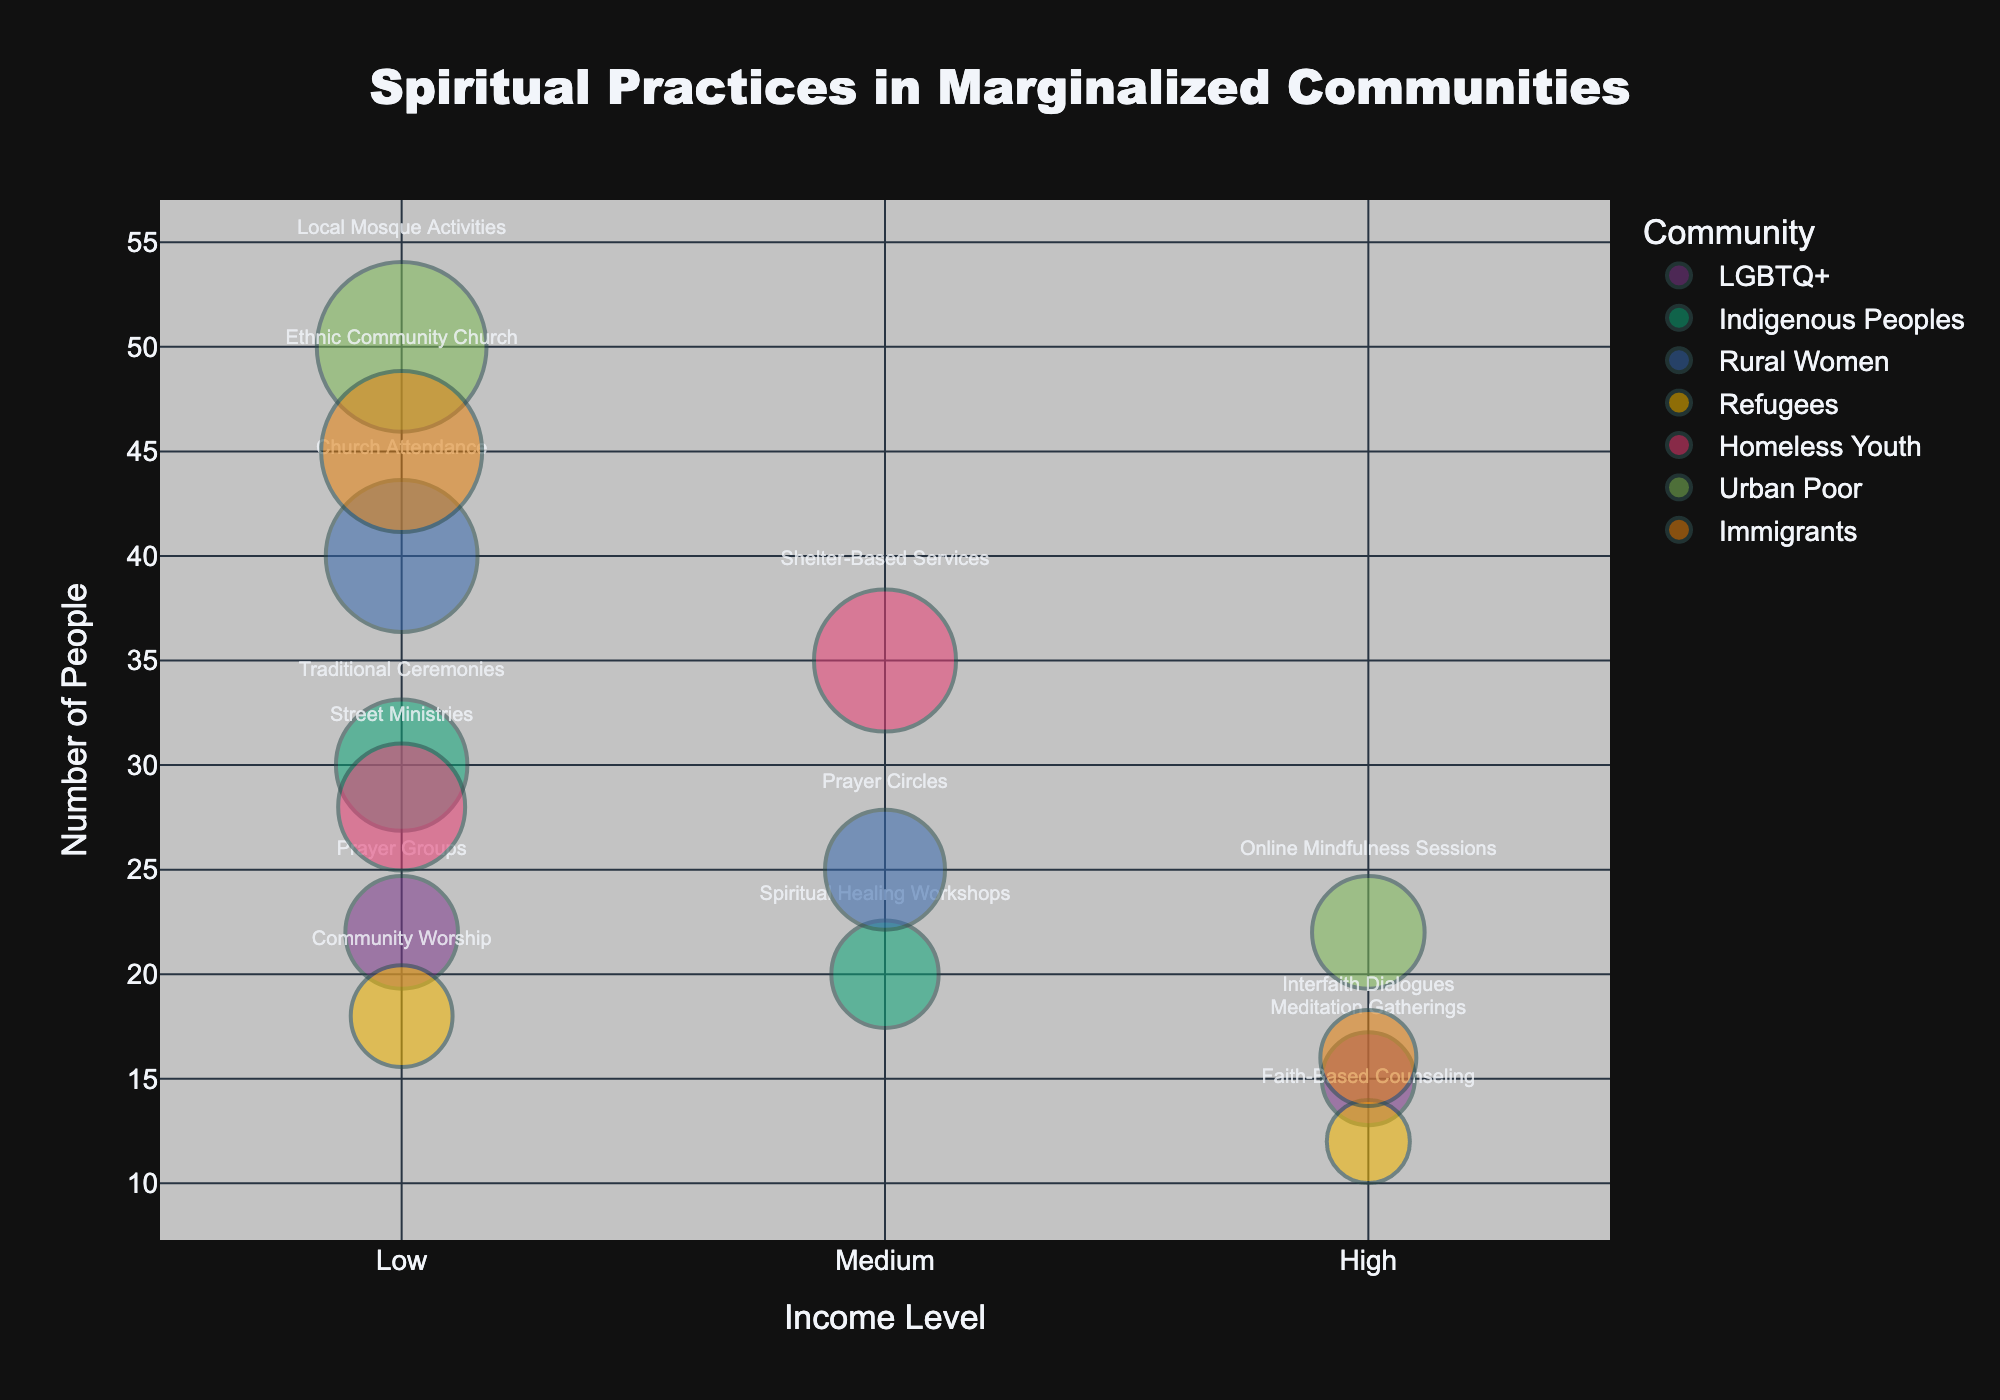Which community has the highest number of people participating in a spiritual practice? The "Urban Poor" community has the highest number of people engaging in "Local Mosque Activities" with a count of 50 people. This is the largest bubble on the chart.
Answer: Urban Poor What is the income level and spiritual practice for the Indigenous Peoples with the largest bubble? The largest bubble for Indigenous Peoples represents 30 people participating in "Traditional Ceremonies" at the "Low" income level.
Answer: Low, Traditional Ceremonies Compare the number of people in "Meditation Gatherings" for the LGBTQ+ community to those in "Online Mindfulness Sessions" for the Urban Poor community. Which has more? "Online Mindfulness Sessions" for the Urban Poor community has 22 people, while "Meditation Gatherings" for the LGBTQ+ community has 15 people.
Answer: Online Mindfulness Sessions What is the total number of people involved in spiritual practices for the "Rural Women" community? Rural Women have 40 people in "Church Attendance" and 25 people in "Prayer Circles," totaling 65 people.
Answer: 65 How many spiritual practices have more than 20 people participating across all communities? Looking at the bubbles, six different practices have more than 20 participants: "Traditional Ceremonies" (30), "Church Attendance" (40), "Prayer Circles" (25), "Street Ministries" (28), "Shelter-Based Services" (35), "Local Mosque Activities" (50), "Ethnic Community Church" (45), and "Online Mindfulness Sessions" (22).
Answer: Six Which community shows the widest range of income levels involved in their spiritual practices? The "LGBTQ+" community shows practices at both "Low" and "High" income levels ("Prayer Groups" and "Meditation Gatherings"), indicating a range from 1 to 3 in the income numeric mapping.
Answer: LGBTQ+ What are the income levels of the spiritual practices for the "Refugees" community? The "Refugees" community has "Community Worship" at the "Low" level and "Faith-Based Counseling" at the "High" level.
Answer: Low, High What spiritual practice has the highest number of people among the "Homeless Youth" community, and what is the count? The "Shelter-Based Services" practice has the highest number of people among "Homeless Youth" with a count of 35.
Answer: Shelter-Based Services, 35 Compare the number of people involved in "Community Worship" for Refugees to those in "Faith-Based Counseling." Which practice has more people? "Community Worship" for Refugees involves 18 people, whereas "Faith-Based Counseling" involves 12 people; therefore, "Community Worship" has more participants.
Answer: Community Worship Which spiritual practice has the lowest number of participants among all the communities, and what is the number? "Faith-Based Counseling" for the Refugees community has the lowest number of participants with a count of 12.
Answer: Faith-Based Counseling, 12 